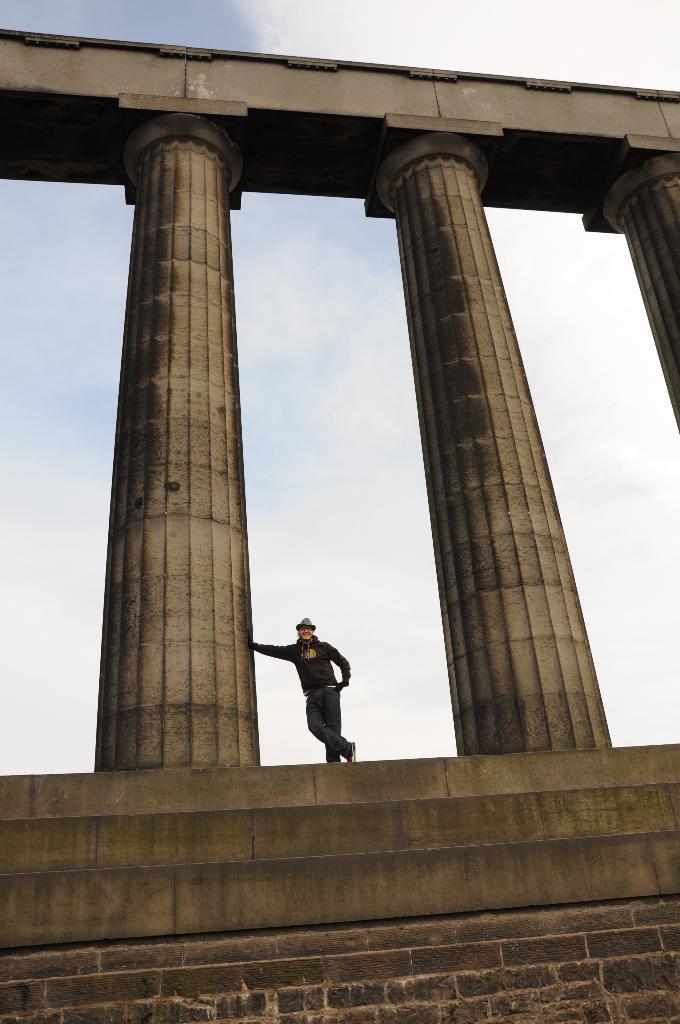How would you summarize this image in a sentence or two? In this picture I can see a person standing on the surface. I can see the pillars. I can see clouds in the sky. 